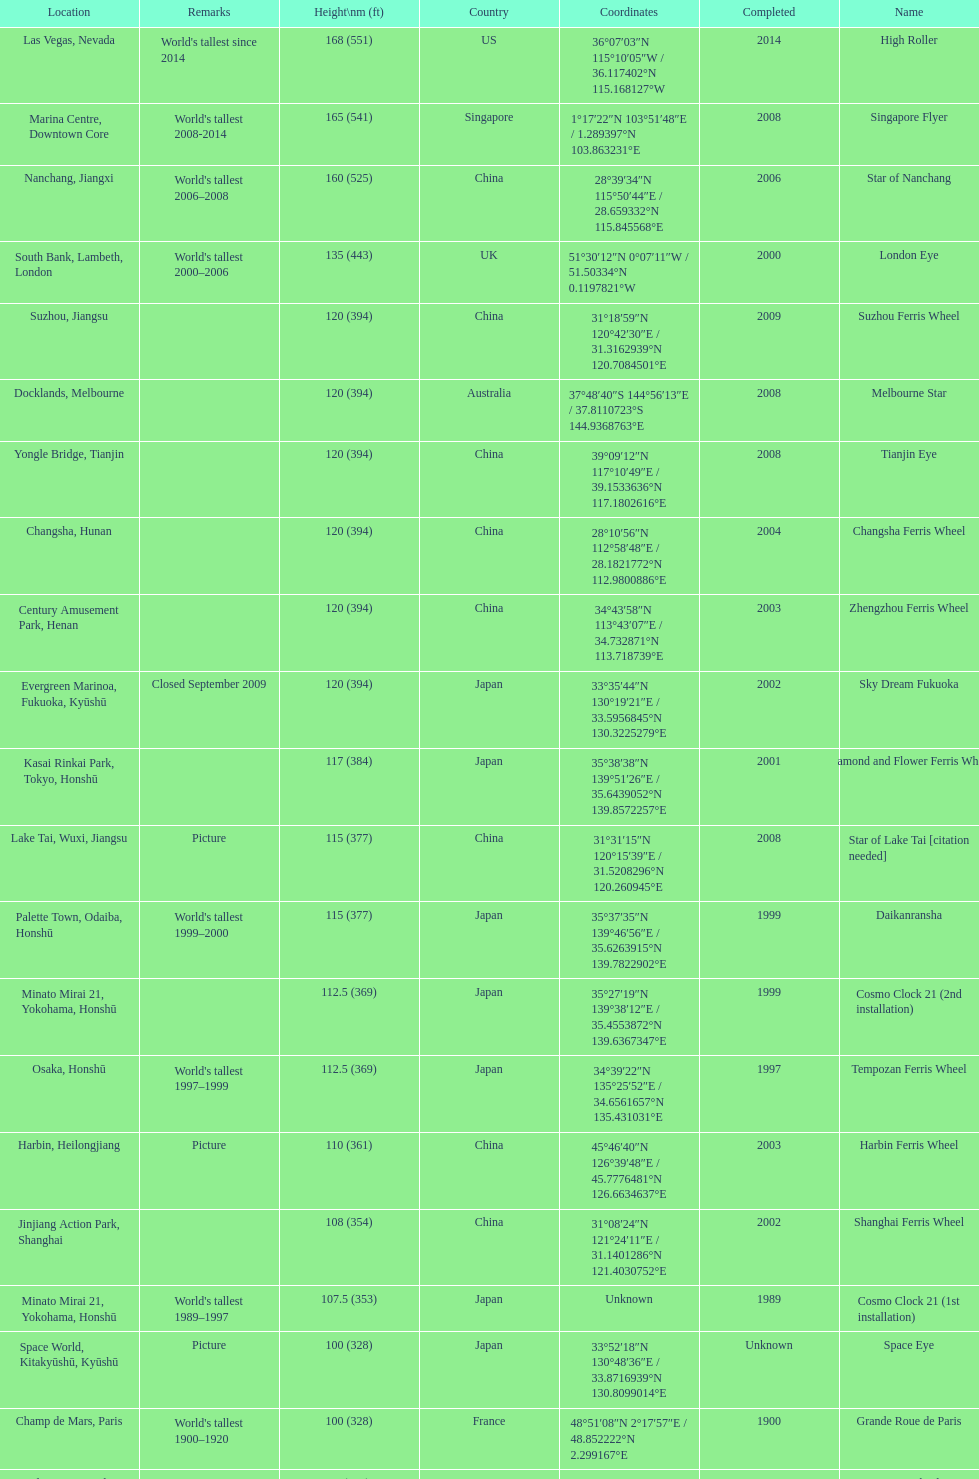Which of the following roller coasters is the oldest: star of lake tai, star of nanchang, melbourne star Star of Nanchang. 